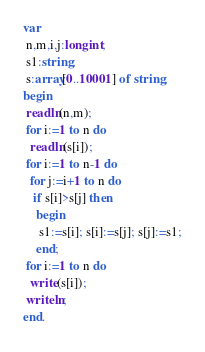Convert code to text. <code><loc_0><loc_0><loc_500><loc_500><_Pascal_>var
 n,m,i,j:longint;
 s1:string;
 s:array[0..10001] of string;
begin
 readln(n,m);
 for i:=1 to n do
  readln(s[i]);
 for i:=1 to n-1 do
  for j:=i+1 to n do
   if s[i]>s[j] then
    begin
     s1:=s[i]; s[i]:=s[j]; s[j]:=s1;
    end;
 for i:=1 to n do
  write(s[i]);
 writeln;
end.</code> 